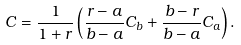<formula> <loc_0><loc_0><loc_500><loc_500>C = \frac { 1 } { 1 + r } \left ( \frac { r - a } { b - a } C _ { b } + \frac { b - r } { b - a } C _ { a } \right ) .</formula> 